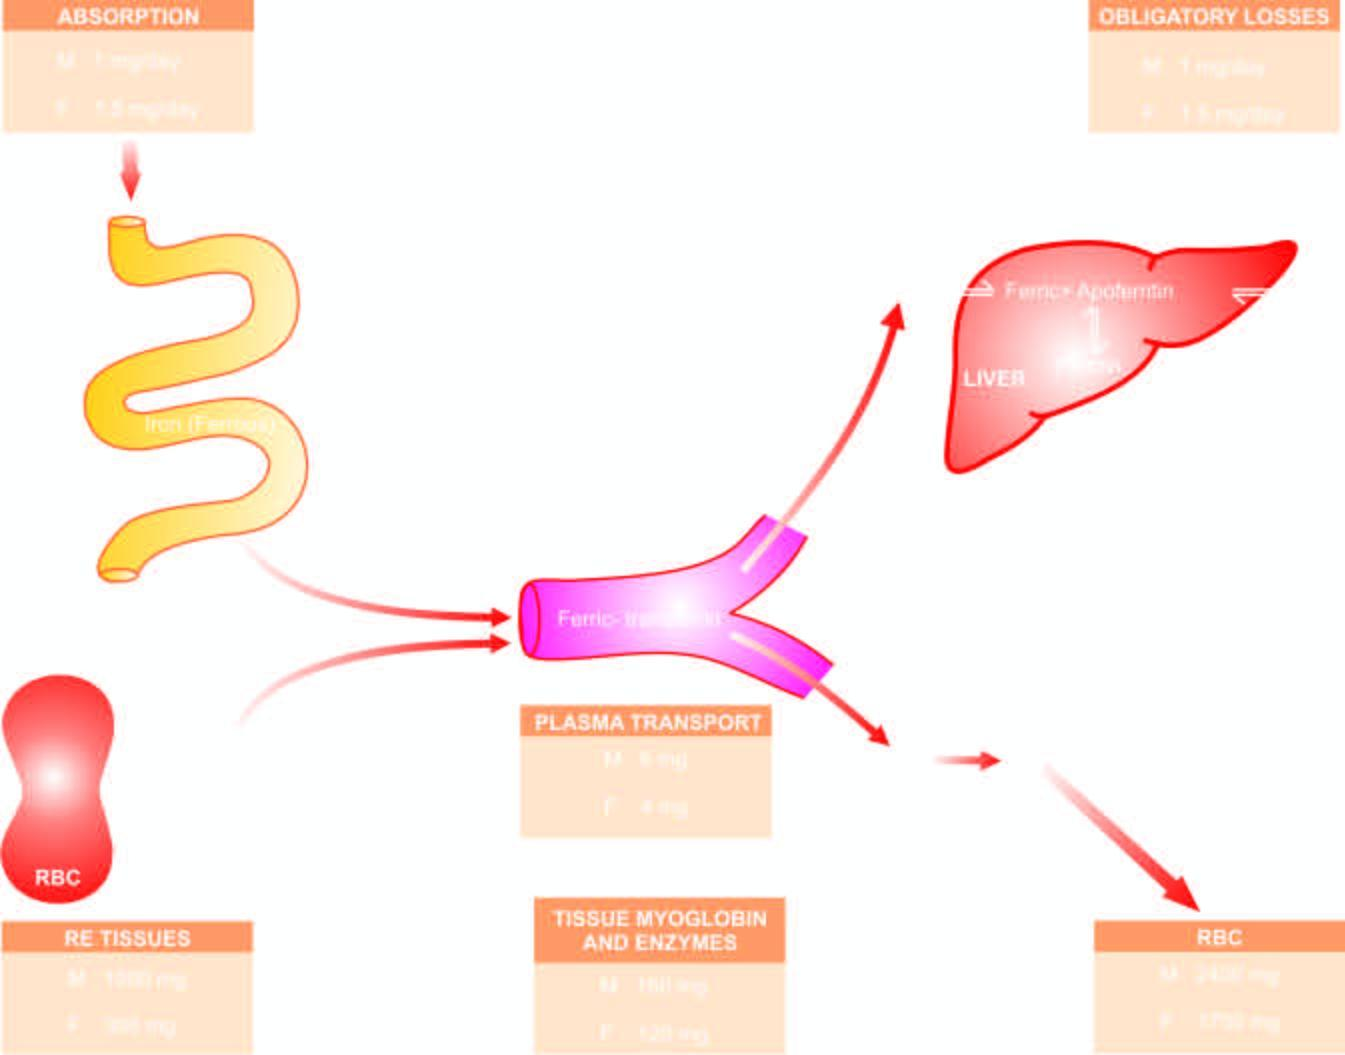the mature red cells are released into circulation , which on completion of whose lifespan of 120 days , die?
Answer the question using a single word or phrase. Their 